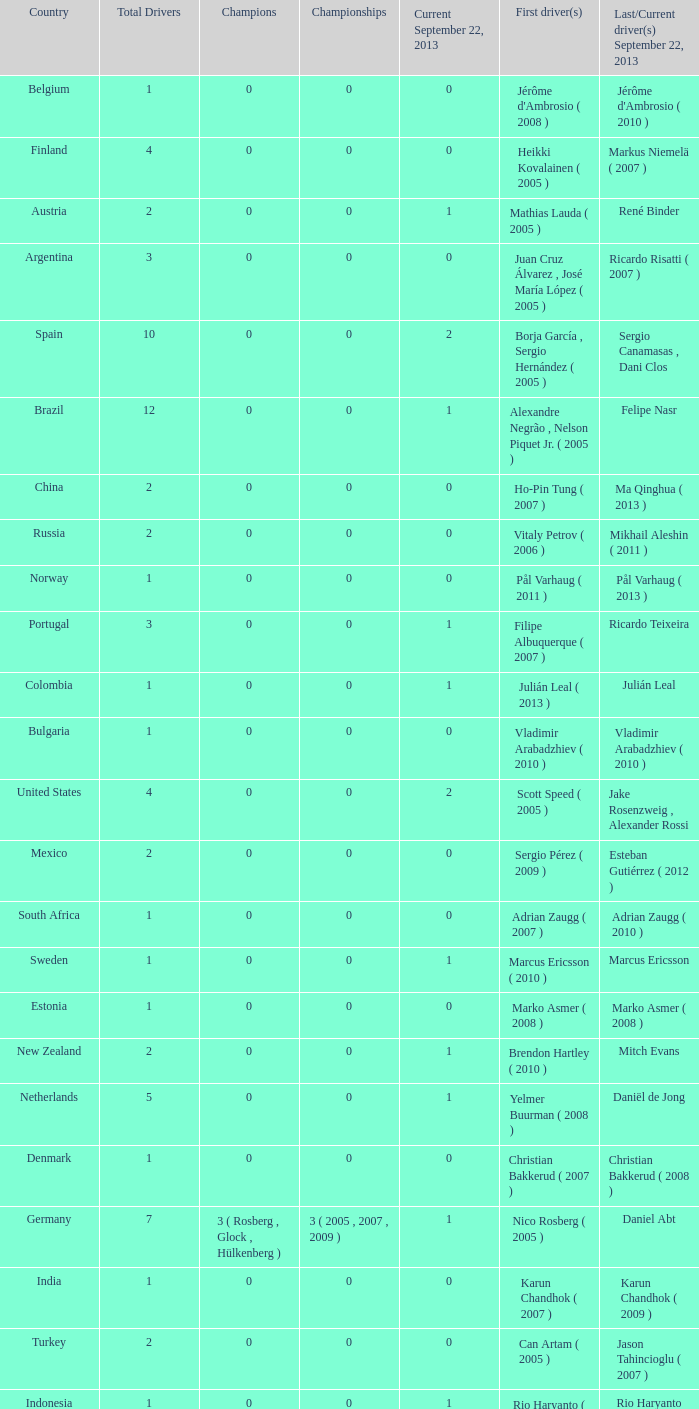How many entries are there for total drivers when the Last driver for september 22, 2013 was gianmarco raimondo? 1.0. 